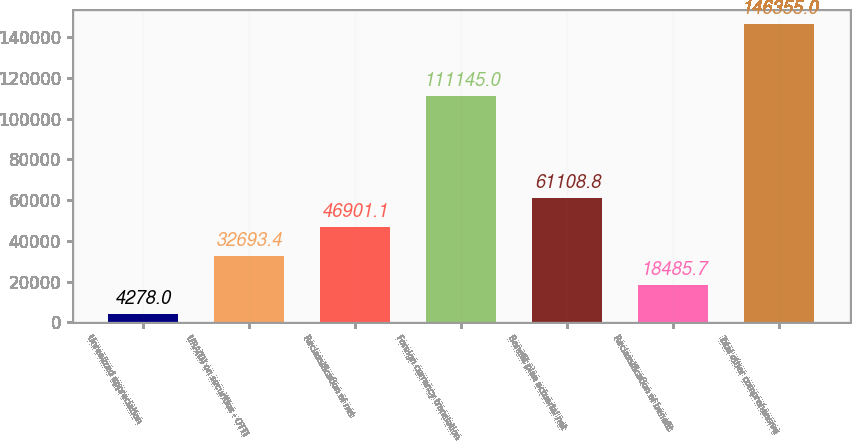Convert chart. <chart><loc_0><loc_0><loc_500><loc_500><bar_chart><fcel>Unrealized appreciation<fcel>URA(D) on securities - OTTI<fcel>Reclassification of net<fcel>Foreign currency translation<fcel>Benefit plan actuarial net<fcel>Reclassification of benefit<fcel>Total other comprehensive<nl><fcel>4278<fcel>32693.4<fcel>46901.1<fcel>111145<fcel>61108.8<fcel>18485.7<fcel>146355<nl></chart> 